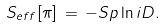Convert formula to latex. <formula><loc_0><loc_0><loc_500><loc_500>S _ { e f f } [ \pi ] \, = \, - S p \ln i D .</formula> 